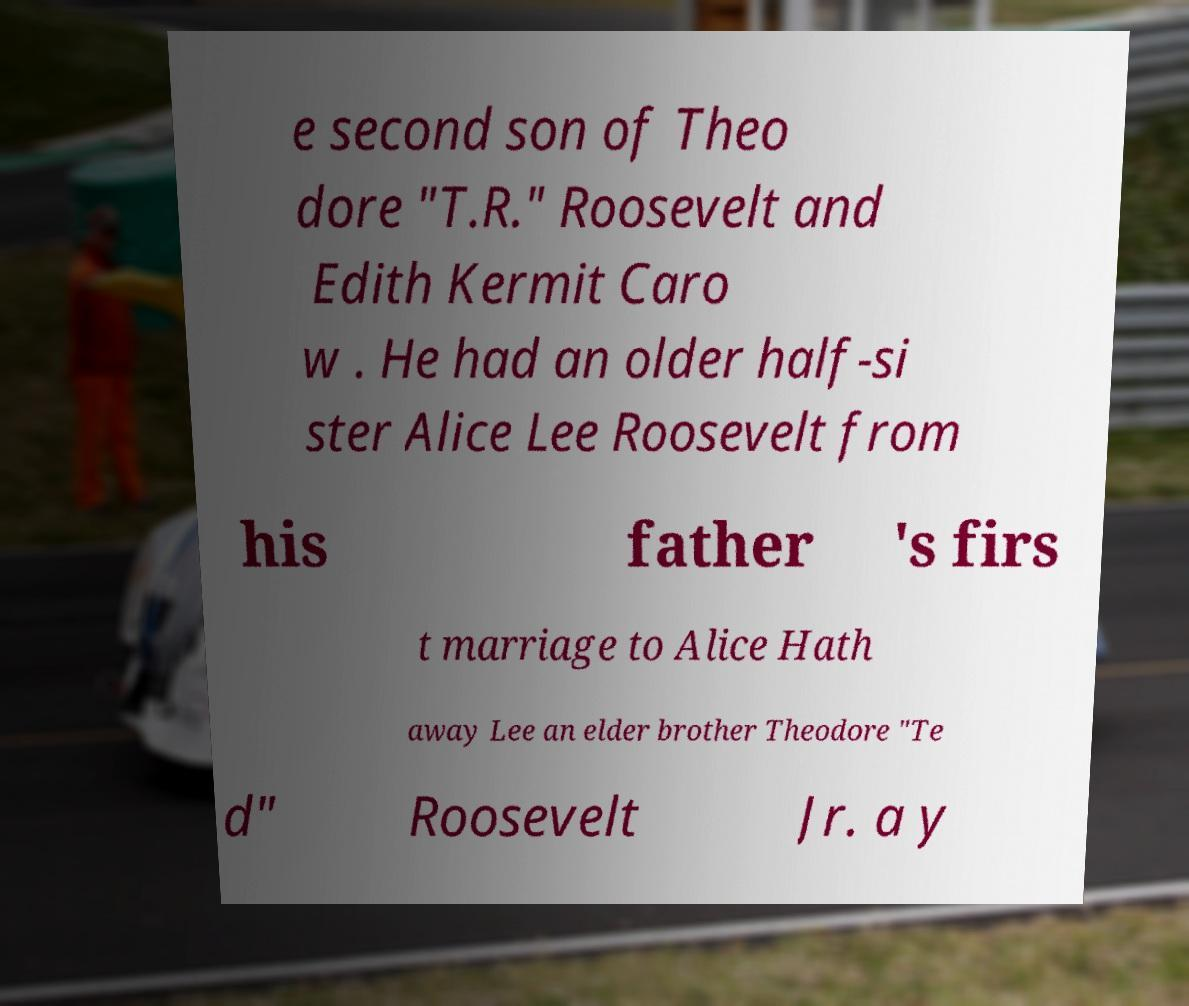Please identify and transcribe the text found in this image. e second son of Theo dore "T.R." Roosevelt and Edith Kermit Caro w . He had an older half-si ster Alice Lee Roosevelt from his father 's firs t marriage to Alice Hath away Lee an elder brother Theodore "Te d" Roosevelt Jr. a y 